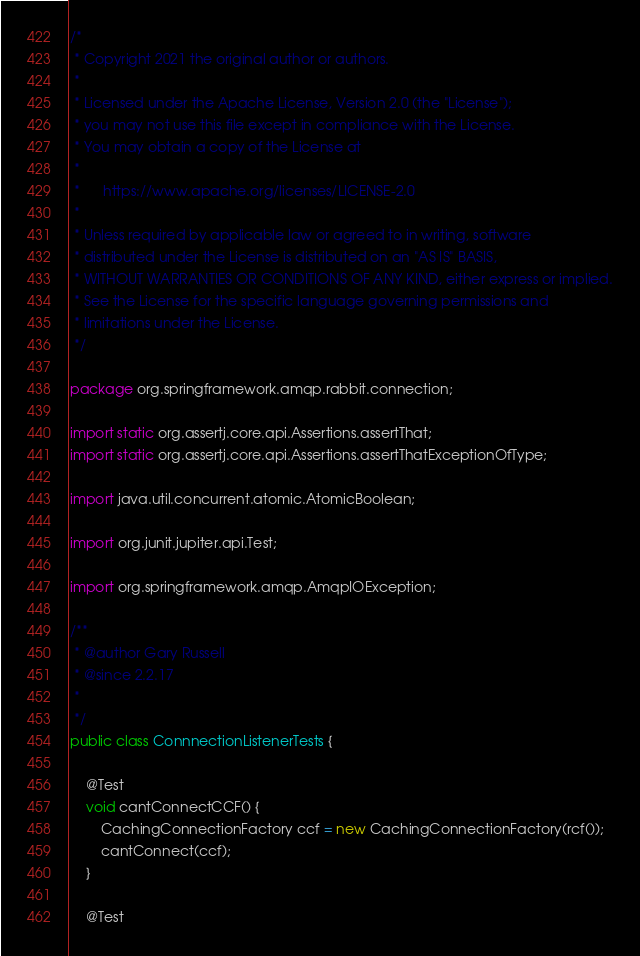Convert code to text. <code><loc_0><loc_0><loc_500><loc_500><_Java_>/*
 * Copyright 2021 the original author or authors.
 *
 * Licensed under the Apache License, Version 2.0 (the "License");
 * you may not use this file except in compliance with the License.
 * You may obtain a copy of the License at
 *
 *      https://www.apache.org/licenses/LICENSE-2.0
 *
 * Unless required by applicable law or agreed to in writing, software
 * distributed under the License is distributed on an "AS IS" BASIS,
 * WITHOUT WARRANTIES OR CONDITIONS OF ANY KIND, either express or implied.
 * See the License for the specific language governing permissions and
 * limitations under the License.
 */

package org.springframework.amqp.rabbit.connection;

import static org.assertj.core.api.Assertions.assertThat;
import static org.assertj.core.api.Assertions.assertThatExceptionOfType;

import java.util.concurrent.atomic.AtomicBoolean;

import org.junit.jupiter.api.Test;

import org.springframework.amqp.AmqpIOException;

/**
 * @author Gary Russell
 * @since 2.2.17
 *
 */
public class ConnnectionListenerTests {

	@Test
	void cantConnectCCF() {
		CachingConnectionFactory ccf = new CachingConnectionFactory(rcf());
		cantConnect(ccf);
	}

	@Test</code> 